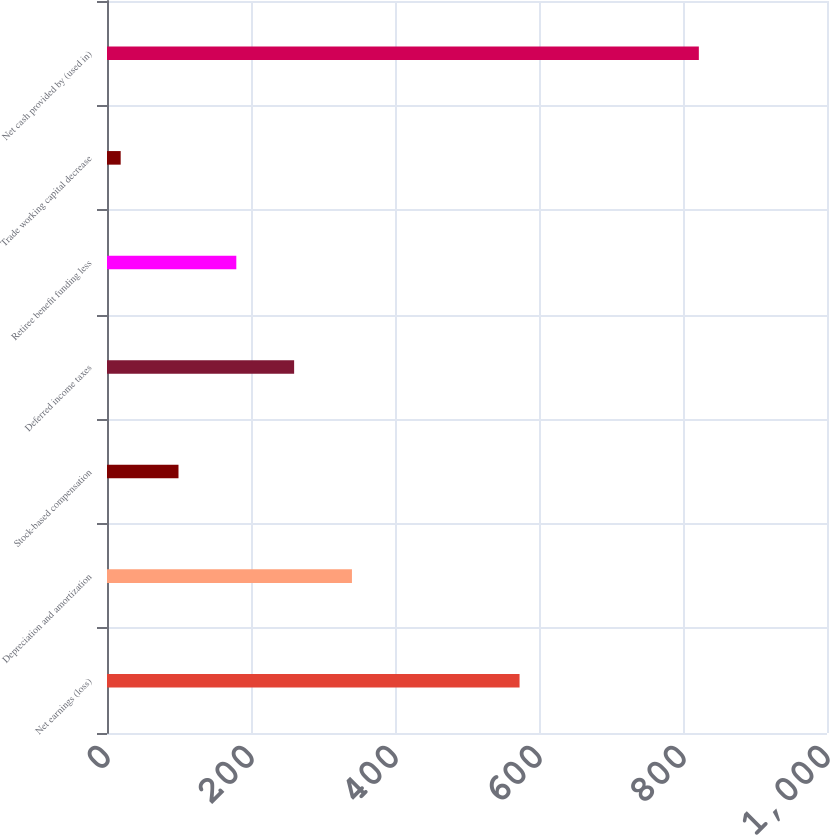Convert chart to OTSL. <chart><loc_0><loc_0><loc_500><loc_500><bar_chart><fcel>Net earnings (loss)<fcel>Depreciation and amortization<fcel>Stock-based compensation<fcel>Deferred income taxes<fcel>Retiree benefit funding less<fcel>Trade working capital decrease<fcel>Net cash provided by (used in)<nl><fcel>573<fcel>340.2<fcel>99.3<fcel>259.9<fcel>179.6<fcel>19<fcel>822<nl></chart> 